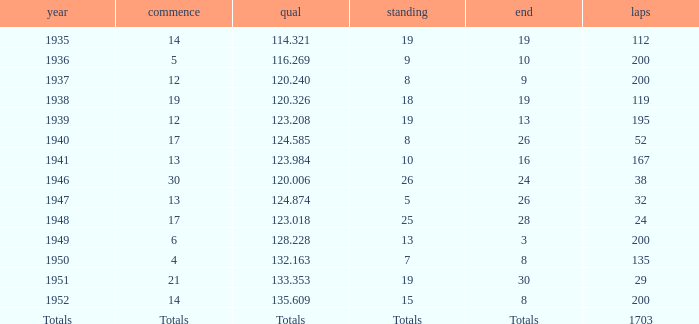The Qual of 120.006 took place in what year? 1946.0. 